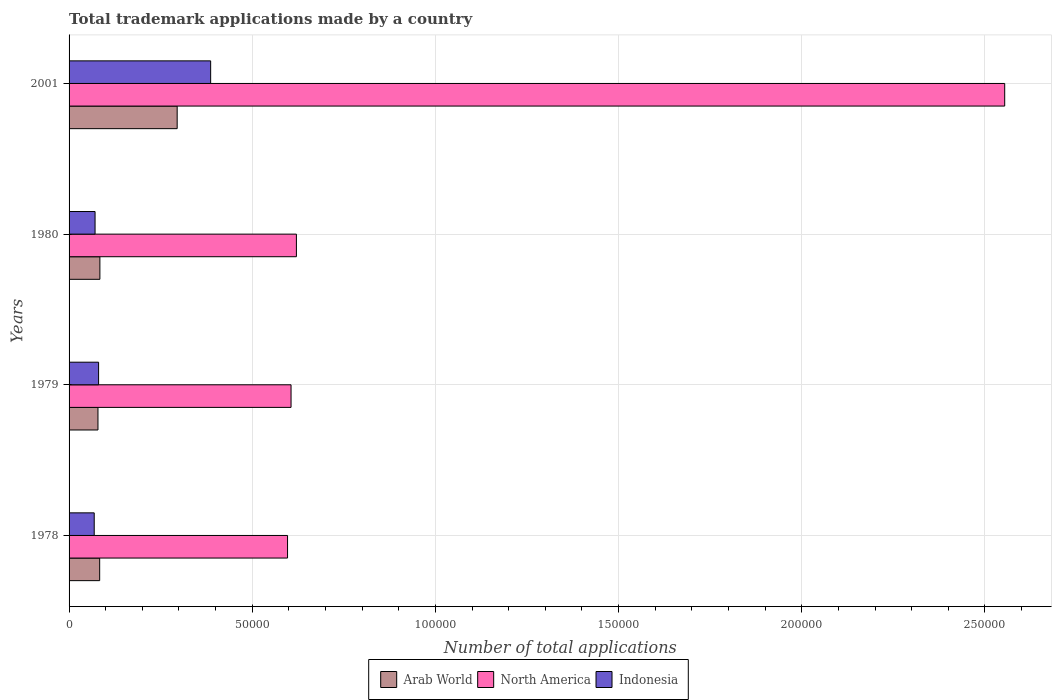How many different coloured bars are there?
Offer a very short reply. 3. How many bars are there on the 3rd tick from the top?
Provide a succinct answer. 3. What is the number of applications made by in North America in 2001?
Your answer should be compact. 2.55e+05. Across all years, what is the maximum number of applications made by in Indonesia?
Make the answer very short. 3.86e+04. Across all years, what is the minimum number of applications made by in Indonesia?
Give a very brief answer. 6866. In which year was the number of applications made by in Arab World maximum?
Provide a succinct answer. 2001. In which year was the number of applications made by in Indonesia minimum?
Offer a very short reply. 1978. What is the total number of applications made by in North America in the graph?
Provide a short and direct response. 4.38e+05. What is the difference between the number of applications made by in North America in 1979 and that in 1980?
Keep it short and to the point. -1463. What is the difference between the number of applications made by in Indonesia in 1979 and the number of applications made by in Arab World in 1978?
Your response must be concise. -294. What is the average number of applications made by in Indonesia per year?
Keep it short and to the point. 1.52e+04. In the year 1978, what is the difference between the number of applications made by in North America and number of applications made by in Indonesia?
Offer a terse response. 5.28e+04. In how many years, is the number of applications made by in Indonesia greater than 150000 ?
Offer a very short reply. 0. What is the ratio of the number of applications made by in Arab World in 1978 to that in 1979?
Your answer should be very brief. 1.06. Is the difference between the number of applications made by in North America in 1979 and 1980 greater than the difference between the number of applications made by in Indonesia in 1979 and 1980?
Your response must be concise. No. What is the difference between the highest and the second highest number of applications made by in Indonesia?
Ensure brevity in your answer.  3.06e+04. What is the difference between the highest and the lowest number of applications made by in Indonesia?
Offer a very short reply. 3.18e+04. What does the 3rd bar from the bottom in 2001 represents?
Offer a terse response. Indonesia. Is it the case that in every year, the sum of the number of applications made by in North America and number of applications made by in Arab World is greater than the number of applications made by in Indonesia?
Keep it short and to the point. Yes. Are all the bars in the graph horizontal?
Provide a succinct answer. Yes. Are the values on the major ticks of X-axis written in scientific E-notation?
Provide a succinct answer. No. Does the graph contain grids?
Your answer should be very brief. Yes. How many legend labels are there?
Your response must be concise. 3. What is the title of the graph?
Offer a terse response. Total trademark applications made by a country. Does "Bhutan" appear as one of the legend labels in the graph?
Make the answer very short. No. What is the label or title of the X-axis?
Offer a terse response. Number of total applications. What is the label or title of the Y-axis?
Give a very brief answer. Years. What is the Number of total applications in Arab World in 1978?
Provide a succinct answer. 8351. What is the Number of total applications in North America in 1978?
Give a very brief answer. 5.96e+04. What is the Number of total applications of Indonesia in 1978?
Keep it short and to the point. 6866. What is the Number of total applications in Arab World in 1979?
Provide a succinct answer. 7889. What is the Number of total applications in North America in 1979?
Your answer should be compact. 6.06e+04. What is the Number of total applications of Indonesia in 1979?
Provide a short and direct response. 8057. What is the Number of total applications of Arab World in 1980?
Your response must be concise. 8411. What is the Number of total applications in North America in 1980?
Ensure brevity in your answer.  6.21e+04. What is the Number of total applications in Indonesia in 1980?
Keep it short and to the point. 7095. What is the Number of total applications of Arab World in 2001?
Keep it short and to the point. 2.95e+04. What is the Number of total applications in North America in 2001?
Give a very brief answer. 2.55e+05. What is the Number of total applications in Indonesia in 2001?
Give a very brief answer. 3.86e+04. Across all years, what is the maximum Number of total applications of Arab World?
Offer a very short reply. 2.95e+04. Across all years, what is the maximum Number of total applications in North America?
Your answer should be compact. 2.55e+05. Across all years, what is the maximum Number of total applications of Indonesia?
Your answer should be compact. 3.86e+04. Across all years, what is the minimum Number of total applications of Arab World?
Offer a terse response. 7889. Across all years, what is the minimum Number of total applications in North America?
Offer a very short reply. 5.96e+04. Across all years, what is the minimum Number of total applications of Indonesia?
Your response must be concise. 6866. What is the total Number of total applications in Arab World in the graph?
Provide a succinct answer. 5.42e+04. What is the total Number of total applications in North America in the graph?
Your answer should be very brief. 4.38e+05. What is the total Number of total applications of Indonesia in the graph?
Make the answer very short. 6.07e+04. What is the difference between the Number of total applications in Arab World in 1978 and that in 1979?
Provide a short and direct response. 462. What is the difference between the Number of total applications in North America in 1978 and that in 1979?
Ensure brevity in your answer.  -955. What is the difference between the Number of total applications of Indonesia in 1978 and that in 1979?
Offer a terse response. -1191. What is the difference between the Number of total applications of Arab World in 1978 and that in 1980?
Make the answer very short. -60. What is the difference between the Number of total applications of North America in 1978 and that in 1980?
Provide a succinct answer. -2418. What is the difference between the Number of total applications of Indonesia in 1978 and that in 1980?
Your response must be concise. -229. What is the difference between the Number of total applications in Arab World in 1978 and that in 2001?
Give a very brief answer. -2.12e+04. What is the difference between the Number of total applications in North America in 1978 and that in 2001?
Give a very brief answer. -1.96e+05. What is the difference between the Number of total applications of Indonesia in 1978 and that in 2001?
Make the answer very short. -3.18e+04. What is the difference between the Number of total applications in Arab World in 1979 and that in 1980?
Your answer should be very brief. -522. What is the difference between the Number of total applications of North America in 1979 and that in 1980?
Ensure brevity in your answer.  -1463. What is the difference between the Number of total applications in Indonesia in 1979 and that in 1980?
Offer a terse response. 962. What is the difference between the Number of total applications in Arab World in 1979 and that in 2001?
Offer a very short reply. -2.16e+04. What is the difference between the Number of total applications of North America in 1979 and that in 2001?
Offer a very short reply. -1.95e+05. What is the difference between the Number of total applications in Indonesia in 1979 and that in 2001?
Provide a short and direct response. -3.06e+04. What is the difference between the Number of total applications in Arab World in 1980 and that in 2001?
Give a very brief answer. -2.11e+04. What is the difference between the Number of total applications of North America in 1980 and that in 2001?
Give a very brief answer. -1.93e+05. What is the difference between the Number of total applications in Indonesia in 1980 and that in 2001?
Provide a succinct answer. -3.16e+04. What is the difference between the Number of total applications in Arab World in 1978 and the Number of total applications in North America in 1979?
Your answer should be compact. -5.22e+04. What is the difference between the Number of total applications in Arab World in 1978 and the Number of total applications in Indonesia in 1979?
Your response must be concise. 294. What is the difference between the Number of total applications of North America in 1978 and the Number of total applications of Indonesia in 1979?
Your answer should be compact. 5.16e+04. What is the difference between the Number of total applications of Arab World in 1978 and the Number of total applications of North America in 1980?
Provide a short and direct response. -5.37e+04. What is the difference between the Number of total applications of Arab World in 1978 and the Number of total applications of Indonesia in 1980?
Offer a terse response. 1256. What is the difference between the Number of total applications of North America in 1978 and the Number of total applications of Indonesia in 1980?
Make the answer very short. 5.25e+04. What is the difference between the Number of total applications of Arab World in 1978 and the Number of total applications of North America in 2001?
Provide a short and direct response. -2.47e+05. What is the difference between the Number of total applications of Arab World in 1978 and the Number of total applications of Indonesia in 2001?
Provide a short and direct response. -3.03e+04. What is the difference between the Number of total applications of North America in 1978 and the Number of total applications of Indonesia in 2001?
Ensure brevity in your answer.  2.10e+04. What is the difference between the Number of total applications in Arab World in 1979 and the Number of total applications in North America in 1980?
Offer a terse response. -5.42e+04. What is the difference between the Number of total applications of Arab World in 1979 and the Number of total applications of Indonesia in 1980?
Offer a terse response. 794. What is the difference between the Number of total applications in North America in 1979 and the Number of total applications in Indonesia in 1980?
Offer a very short reply. 5.35e+04. What is the difference between the Number of total applications in Arab World in 1979 and the Number of total applications in North America in 2001?
Provide a short and direct response. -2.48e+05. What is the difference between the Number of total applications of Arab World in 1979 and the Number of total applications of Indonesia in 2001?
Your answer should be very brief. -3.08e+04. What is the difference between the Number of total applications of North America in 1979 and the Number of total applications of Indonesia in 2001?
Ensure brevity in your answer.  2.19e+04. What is the difference between the Number of total applications of Arab World in 1980 and the Number of total applications of North America in 2001?
Provide a succinct answer. -2.47e+05. What is the difference between the Number of total applications of Arab World in 1980 and the Number of total applications of Indonesia in 2001?
Offer a terse response. -3.02e+04. What is the difference between the Number of total applications in North America in 1980 and the Number of total applications in Indonesia in 2001?
Offer a terse response. 2.34e+04. What is the average Number of total applications in Arab World per year?
Provide a short and direct response. 1.35e+04. What is the average Number of total applications in North America per year?
Your answer should be compact. 1.09e+05. What is the average Number of total applications of Indonesia per year?
Offer a very short reply. 1.52e+04. In the year 1978, what is the difference between the Number of total applications in Arab World and Number of total applications in North America?
Your response must be concise. -5.13e+04. In the year 1978, what is the difference between the Number of total applications in Arab World and Number of total applications in Indonesia?
Offer a very short reply. 1485. In the year 1978, what is the difference between the Number of total applications of North America and Number of total applications of Indonesia?
Keep it short and to the point. 5.28e+04. In the year 1979, what is the difference between the Number of total applications in Arab World and Number of total applications in North America?
Your response must be concise. -5.27e+04. In the year 1979, what is the difference between the Number of total applications in Arab World and Number of total applications in Indonesia?
Provide a short and direct response. -168. In the year 1979, what is the difference between the Number of total applications in North America and Number of total applications in Indonesia?
Your answer should be compact. 5.25e+04. In the year 1980, what is the difference between the Number of total applications of Arab World and Number of total applications of North America?
Keep it short and to the point. -5.36e+04. In the year 1980, what is the difference between the Number of total applications of Arab World and Number of total applications of Indonesia?
Make the answer very short. 1316. In the year 1980, what is the difference between the Number of total applications in North America and Number of total applications in Indonesia?
Your response must be concise. 5.50e+04. In the year 2001, what is the difference between the Number of total applications of Arab World and Number of total applications of North America?
Keep it short and to the point. -2.26e+05. In the year 2001, what is the difference between the Number of total applications of Arab World and Number of total applications of Indonesia?
Ensure brevity in your answer.  -9139. In the year 2001, what is the difference between the Number of total applications in North America and Number of total applications in Indonesia?
Keep it short and to the point. 2.17e+05. What is the ratio of the Number of total applications in Arab World in 1978 to that in 1979?
Provide a succinct answer. 1.06. What is the ratio of the Number of total applications in North America in 1978 to that in 1979?
Keep it short and to the point. 0.98. What is the ratio of the Number of total applications of Indonesia in 1978 to that in 1979?
Provide a succinct answer. 0.85. What is the ratio of the Number of total applications of North America in 1978 to that in 1980?
Offer a terse response. 0.96. What is the ratio of the Number of total applications in Arab World in 1978 to that in 2001?
Your answer should be very brief. 0.28. What is the ratio of the Number of total applications in North America in 1978 to that in 2001?
Offer a terse response. 0.23. What is the ratio of the Number of total applications of Indonesia in 1978 to that in 2001?
Provide a short and direct response. 0.18. What is the ratio of the Number of total applications in Arab World in 1979 to that in 1980?
Your answer should be very brief. 0.94. What is the ratio of the Number of total applications in North America in 1979 to that in 1980?
Your response must be concise. 0.98. What is the ratio of the Number of total applications of Indonesia in 1979 to that in 1980?
Your answer should be very brief. 1.14. What is the ratio of the Number of total applications of Arab World in 1979 to that in 2001?
Provide a succinct answer. 0.27. What is the ratio of the Number of total applications of North America in 1979 to that in 2001?
Your answer should be very brief. 0.24. What is the ratio of the Number of total applications in Indonesia in 1979 to that in 2001?
Offer a terse response. 0.21. What is the ratio of the Number of total applications of Arab World in 1980 to that in 2001?
Offer a terse response. 0.28. What is the ratio of the Number of total applications in North America in 1980 to that in 2001?
Make the answer very short. 0.24. What is the ratio of the Number of total applications in Indonesia in 1980 to that in 2001?
Keep it short and to the point. 0.18. What is the difference between the highest and the second highest Number of total applications of Arab World?
Offer a very short reply. 2.11e+04. What is the difference between the highest and the second highest Number of total applications in North America?
Keep it short and to the point. 1.93e+05. What is the difference between the highest and the second highest Number of total applications in Indonesia?
Ensure brevity in your answer.  3.06e+04. What is the difference between the highest and the lowest Number of total applications in Arab World?
Your answer should be compact. 2.16e+04. What is the difference between the highest and the lowest Number of total applications in North America?
Your answer should be compact. 1.96e+05. What is the difference between the highest and the lowest Number of total applications in Indonesia?
Your answer should be compact. 3.18e+04. 